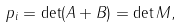<formula> <loc_0><loc_0><loc_500><loc_500>p _ { i } = \det ( A + B ) = \det M ,</formula> 